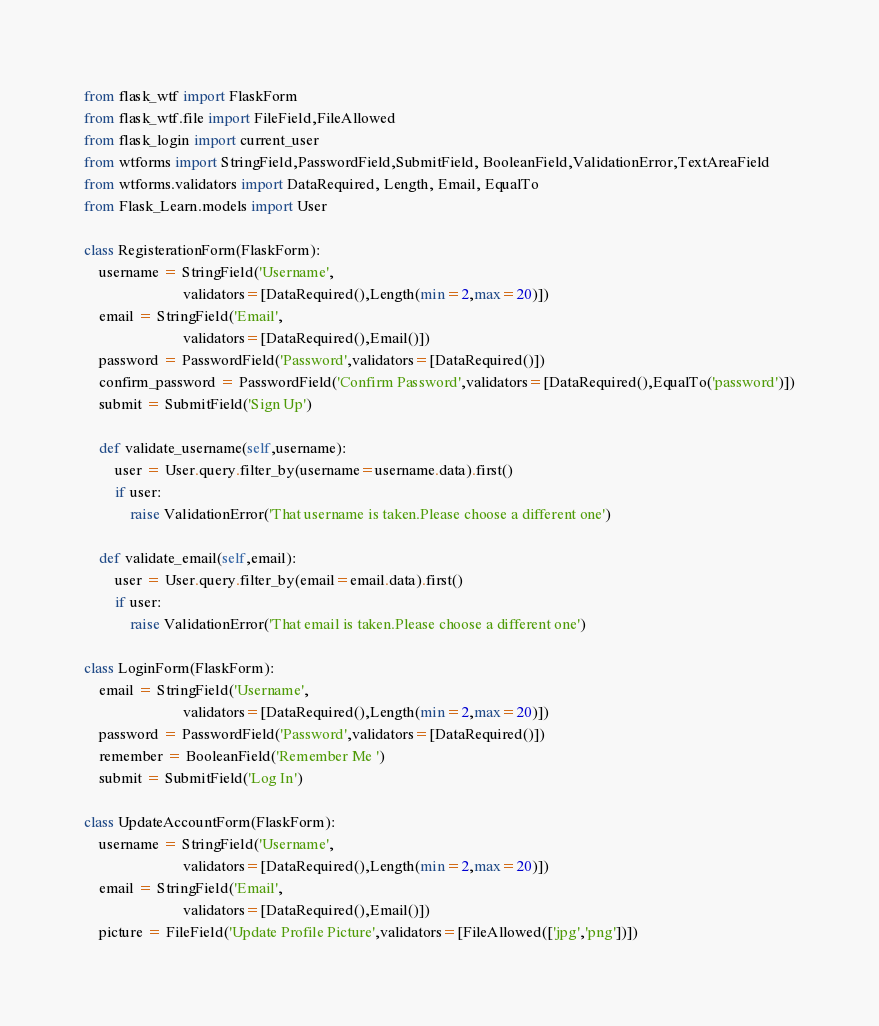<code> <loc_0><loc_0><loc_500><loc_500><_Python_>from flask_wtf import FlaskForm
from flask_wtf.file import FileField,FileAllowed
from flask_login import current_user
from wtforms import StringField,PasswordField,SubmitField, BooleanField,ValidationError,TextAreaField
from wtforms.validators import DataRequired, Length, Email, EqualTo
from Flask_Learn.models import User

class RegisterationForm(FlaskForm):
    username = StringField('Username',
                          validators=[DataRequired(),Length(min=2,max=20)])
    email = StringField('Email',
                          validators=[DataRequired(),Email()])
    password = PasswordField('Password',validators=[DataRequired()])
    confirm_password = PasswordField('Confirm Password',validators=[DataRequired(),EqualTo('password')])
    submit = SubmitField('Sign Up')

    def validate_username(self,username):
        user = User.query.filter_by(username=username.data).first()
        if user:
            raise ValidationError('That username is taken.Please choose a different one')
    
    def validate_email(self,email):
        user = User.query.filter_by(email=email.data).first()
        if user:
            raise ValidationError('That email is taken.Please choose a different one')

class LoginForm(FlaskForm):
    email = StringField('Username',
                          validators=[DataRequired(),Length(min=2,max=20)])
    password = PasswordField('Password',validators=[DataRequired()])
    remember = BooleanField('Remember Me ')
    submit = SubmitField('Log In')

class UpdateAccountForm(FlaskForm):
    username = StringField('Username',
                          validators=[DataRequired(),Length(min=2,max=20)])
    email = StringField('Email',
                          validators=[DataRequired(),Email()])
    picture = FileField('Update Profile Picture',validators=[FileAllowed(['jpg','png'])])</code> 